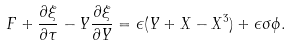<formula> <loc_0><loc_0><loc_500><loc_500>F + \frac { \partial \xi } { \partial \tau } - Y \frac { \partial \xi } { \partial Y } = \epsilon ( Y + X - X ^ { 3 } ) + \epsilon \sigma \phi .</formula> 